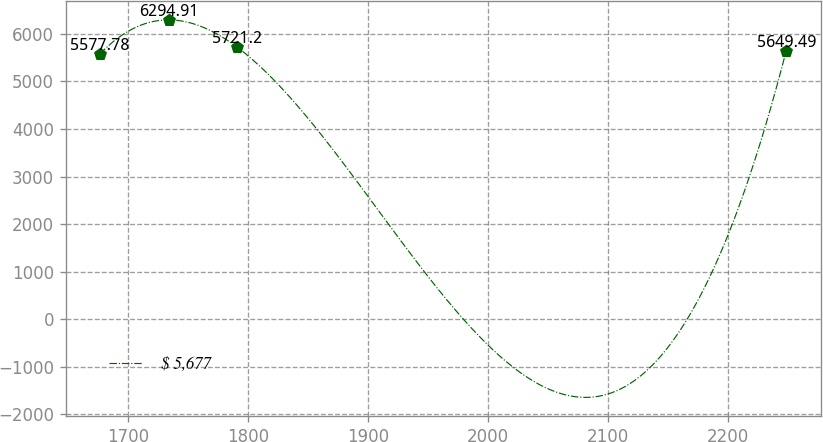Convert chart to OTSL. <chart><loc_0><loc_0><loc_500><loc_500><line_chart><ecel><fcel>$ 5,677<nl><fcel>1676.8<fcel>5577.78<nl><fcel>1733.99<fcel>6294.91<nl><fcel>1791.18<fcel>5721.2<nl><fcel>2248.75<fcel>5649.49<nl></chart> 